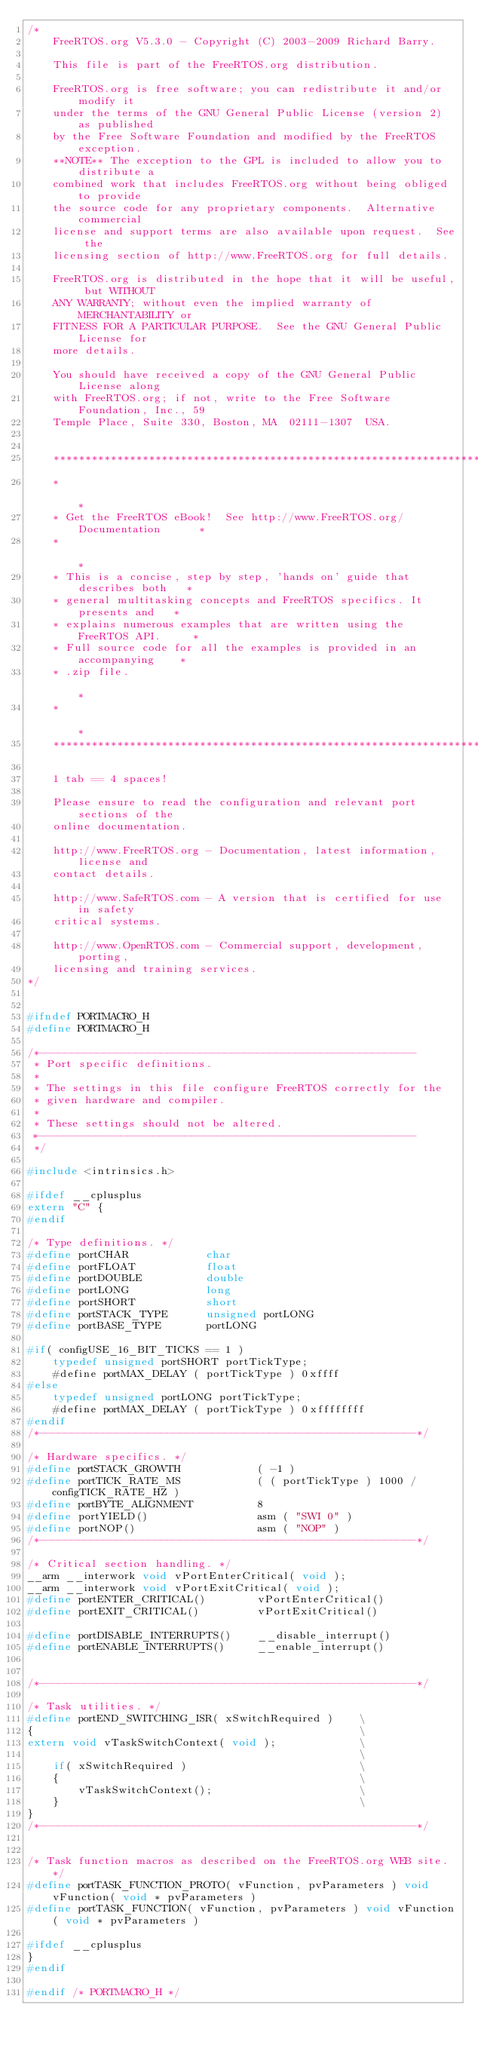<code> <loc_0><loc_0><loc_500><loc_500><_C_>/*
	FreeRTOS.org V5.3.0 - Copyright (C) 2003-2009 Richard Barry.

	This file is part of the FreeRTOS.org distribution.

	FreeRTOS.org is free software; you can redistribute it and/or modify it
	under the terms of the GNU General Public License (version 2) as published
	by the Free Software Foundation and modified by the FreeRTOS exception.
	**NOTE** The exception to the GPL is included to allow you to distribute a
	combined work that includes FreeRTOS.org without being obliged to provide
	the source code for any proprietary components.  Alternative commercial
	license and support terms are also available upon request.  See the 
	licensing section of http://www.FreeRTOS.org for full details.

	FreeRTOS.org is distributed in the hope that it will be useful,	but WITHOUT
	ANY WARRANTY; without even the implied warranty of MERCHANTABILITY or
	FITNESS FOR A PARTICULAR PURPOSE.  See the GNU General Public License for
	more details.

	You should have received a copy of the GNU General Public License along
	with FreeRTOS.org; if not, write to the Free Software Foundation, Inc., 59
	Temple Place, Suite 330, Boston, MA  02111-1307  USA.


	***************************************************************************
	*                                                                         *
	* Get the FreeRTOS eBook!  See http://www.FreeRTOS.org/Documentation      *
	*                                                                         *
	* This is a concise, step by step, 'hands on' guide that describes both   *
	* general multitasking concepts and FreeRTOS specifics. It presents and   *
	* explains numerous examples that are written using the FreeRTOS API.     *
	* Full source code for all the examples is provided in an accompanying    *
	* .zip file.                                                              *
	*                                                                         *
	***************************************************************************

	1 tab == 4 spaces!

	Please ensure to read the configuration and relevant port sections of the
	online documentation.

	http://www.FreeRTOS.org - Documentation, latest information, license and
	contact details.

	http://www.SafeRTOS.com - A version that is certified for use in safety
	critical systems.

	http://www.OpenRTOS.com - Commercial support, development, porting,
	licensing and training services.
*/


#ifndef PORTMACRO_H
#define PORTMACRO_H

/*-----------------------------------------------------------
 * Port specific definitions.
 *
 * The settings in this file configure FreeRTOS correctly for the
 * given hardware and compiler.
 *
 * These settings should not be altered.
 *-----------------------------------------------------------
 */

#include <intrinsics.h>

#ifdef __cplusplus
extern "C" {
#endif

/* Type definitions. */
#define portCHAR			char
#define portFLOAT			float
#define portDOUBLE			double
#define portLONG			long
#define portSHORT			short
#define portSTACK_TYPE		unsigned portLONG
#define portBASE_TYPE		portLONG

#if( configUSE_16_BIT_TICKS == 1 )
	typedef unsigned portSHORT portTickType;
	#define portMAX_DELAY ( portTickType ) 0xffff
#else
	typedef unsigned portLONG portTickType;
	#define portMAX_DELAY ( portTickType ) 0xffffffff
#endif
/*-----------------------------------------------------------*/	

/* Hardware specifics. */
#define portSTACK_GROWTH			( -1 )
#define portTICK_RATE_MS			( ( portTickType ) 1000 / configTICK_RATE_HZ )
#define portBYTE_ALIGNMENT			8
#define portYIELD()					asm ( "SWI 0" )
#define portNOP()					asm ( "NOP" )
/*-----------------------------------------------------------*/	

/* Critical section handling. */
__arm __interwork void vPortEnterCritical( void );
__arm __interwork void vPortExitCritical( void );
#define portENTER_CRITICAL()		vPortEnterCritical()
#define portEXIT_CRITICAL()			vPortExitCritical()

#define portDISABLE_INTERRUPTS()	__disable_interrupt()
#define portENABLE_INTERRUPTS()		__enable_interrupt()


/*-----------------------------------------------------------*/	

/* Task utilities. */
#define portEND_SWITCHING_ISR( xSwitchRequired ) 	\
{													\
extern void vTaskSwitchContext( void );				\
													\
	if( xSwitchRequired ) 							\
	{												\
		vTaskSwitchContext();						\
	}												\
}
/*-----------------------------------------------------------*/	


/* Task function macros as described on the FreeRTOS.org WEB site. */
#define portTASK_FUNCTION_PROTO( vFunction, pvParameters ) void vFunction( void * pvParameters )
#define portTASK_FUNCTION( vFunction, pvParameters ) void vFunction( void * pvParameters )

#ifdef __cplusplus
}
#endif

#endif /* PORTMACRO_H */


</code> 